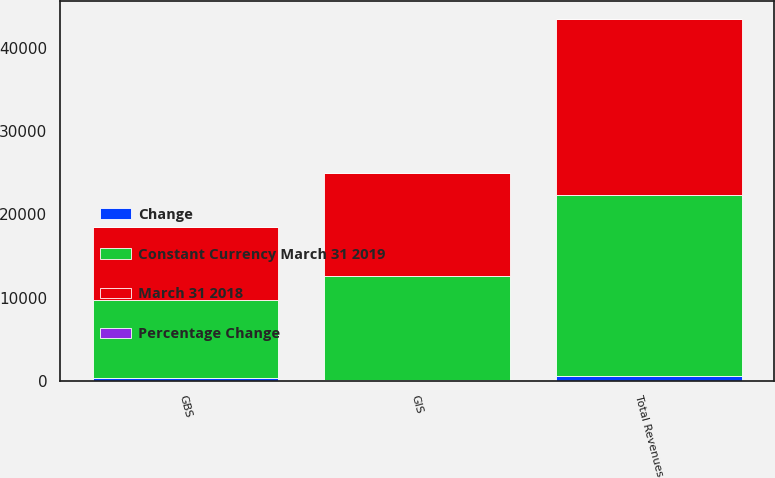<chart> <loc_0><loc_0><loc_500><loc_500><stacked_bar_chart><ecel><fcel>GBS<fcel>GIS<fcel>Total Revenues<nl><fcel>March 31 2018<fcel>8823<fcel>12282<fcel>21105<nl><fcel>Constant Currency March 31 2019<fcel>9254<fcel>12479<fcel>21733<nl><fcel>Change<fcel>431<fcel>197<fcel>628<nl><fcel>Percentage Change<fcel>4.7<fcel>1.6<fcel>2.9<nl></chart> 